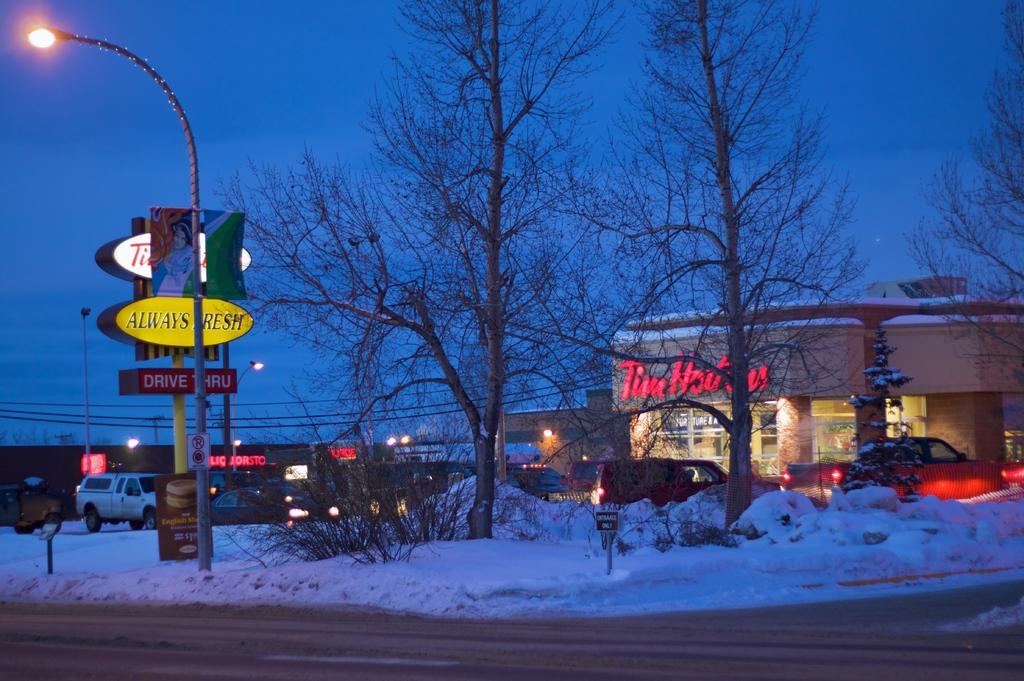Outside what store is the pickup truck parked?
Your response must be concise. Tim hortons. Is the food always fresh according to the yellow sign?
Make the answer very short. Yes. 